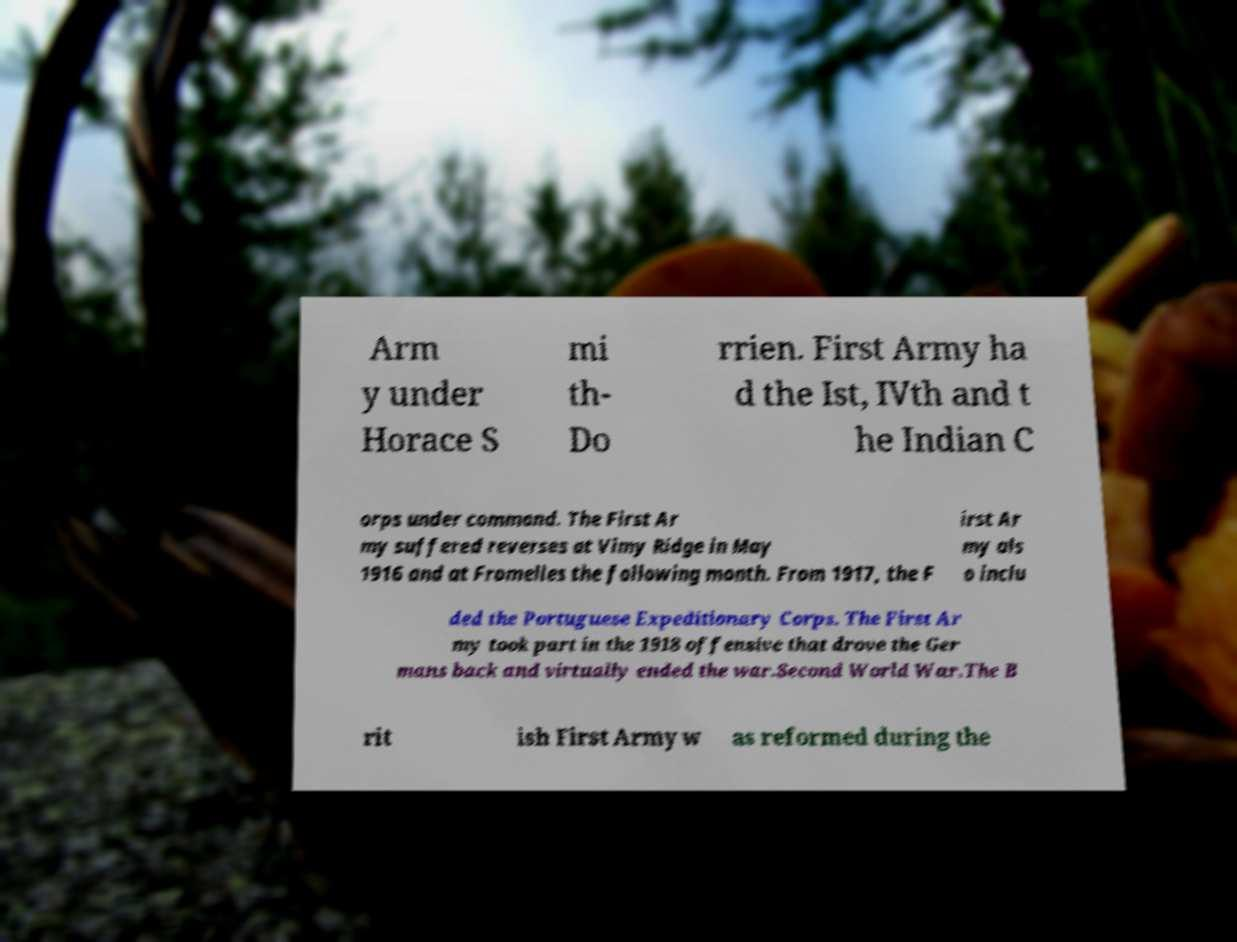Could you extract and type out the text from this image? Arm y under Horace S mi th- Do rrien. First Army ha d the Ist, IVth and t he Indian C orps under command. The First Ar my suffered reverses at Vimy Ridge in May 1916 and at Fromelles the following month. From 1917, the F irst Ar my als o inclu ded the Portuguese Expeditionary Corps. The First Ar my took part in the 1918 offensive that drove the Ger mans back and virtually ended the war.Second World War.The B rit ish First Army w as reformed during the 